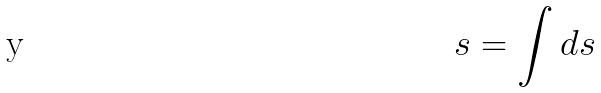Convert formula to latex. <formula><loc_0><loc_0><loc_500><loc_500>s = \int d s</formula> 